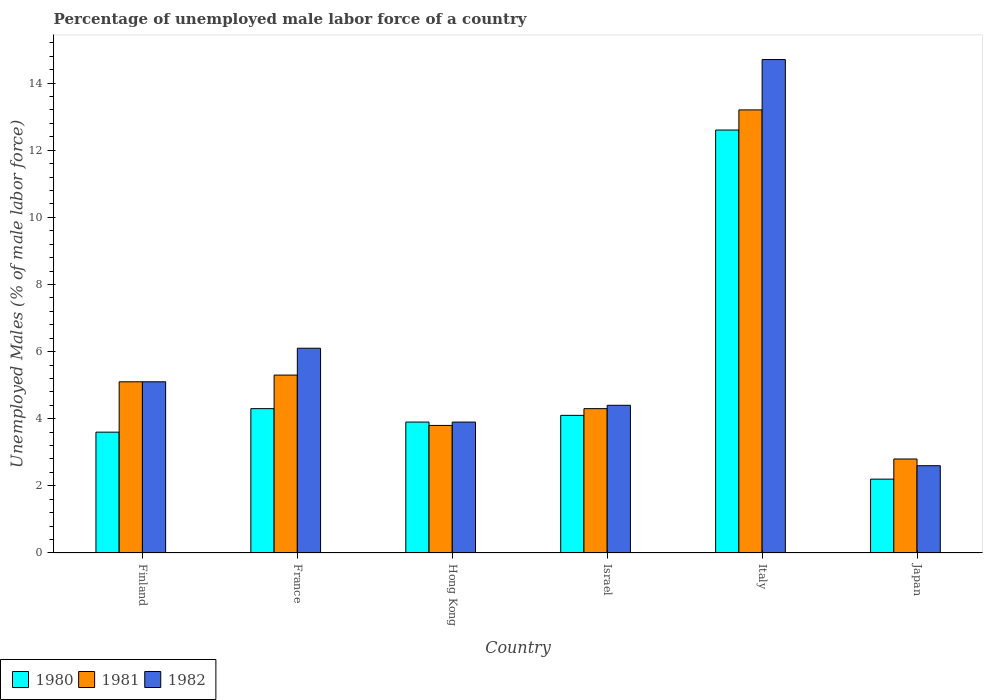How many different coloured bars are there?
Your answer should be very brief. 3. Are the number of bars per tick equal to the number of legend labels?
Your answer should be very brief. Yes. How many bars are there on the 5th tick from the right?
Provide a succinct answer. 3. What is the label of the 3rd group of bars from the left?
Make the answer very short. Hong Kong. What is the percentage of unemployed male labor force in 1981 in France?
Your answer should be very brief. 5.3. Across all countries, what is the maximum percentage of unemployed male labor force in 1982?
Provide a succinct answer. 14.7. Across all countries, what is the minimum percentage of unemployed male labor force in 1982?
Offer a very short reply. 2.6. In which country was the percentage of unemployed male labor force in 1980 maximum?
Your answer should be compact. Italy. What is the total percentage of unemployed male labor force in 1980 in the graph?
Give a very brief answer. 30.7. What is the difference between the percentage of unemployed male labor force in 1981 in France and that in Japan?
Offer a very short reply. 2.5. What is the difference between the percentage of unemployed male labor force in 1982 in Finland and the percentage of unemployed male labor force in 1980 in France?
Provide a succinct answer. 0.8. What is the average percentage of unemployed male labor force in 1981 per country?
Your response must be concise. 5.75. What is the difference between the percentage of unemployed male labor force of/in 1981 and percentage of unemployed male labor force of/in 1982 in Israel?
Your answer should be very brief. -0.1. What is the ratio of the percentage of unemployed male labor force in 1981 in Finland to that in Israel?
Offer a very short reply. 1.19. Is the difference between the percentage of unemployed male labor force in 1981 in Hong Kong and Italy greater than the difference between the percentage of unemployed male labor force in 1982 in Hong Kong and Italy?
Your response must be concise. Yes. What is the difference between the highest and the second highest percentage of unemployed male labor force in 1981?
Ensure brevity in your answer.  -7.9. What is the difference between the highest and the lowest percentage of unemployed male labor force in 1982?
Offer a very short reply. 12.1. In how many countries, is the percentage of unemployed male labor force in 1981 greater than the average percentage of unemployed male labor force in 1981 taken over all countries?
Your answer should be compact. 1. What does the 1st bar from the right in Japan represents?
Keep it short and to the point. 1982. How many bars are there?
Make the answer very short. 18. Are all the bars in the graph horizontal?
Offer a very short reply. No. How many countries are there in the graph?
Provide a succinct answer. 6. Where does the legend appear in the graph?
Make the answer very short. Bottom left. How many legend labels are there?
Your response must be concise. 3. What is the title of the graph?
Provide a succinct answer. Percentage of unemployed male labor force of a country. Does "1966" appear as one of the legend labels in the graph?
Make the answer very short. No. What is the label or title of the Y-axis?
Your answer should be compact. Unemployed Males (% of male labor force). What is the Unemployed Males (% of male labor force) in 1980 in Finland?
Provide a short and direct response. 3.6. What is the Unemployed Males (% of male labor force) in 1981 in Finland?
Make the answer very short. 5.1. What is the Unemployed Males (% of male labor force) of 1982 in Finland?
Your answer should be very brief. 5.1. What is the Unemployed Males (% of male labor force) in 1980 in France?
Keep it short and to the point. 4.3. What is the Unemployed Males (% of male labor force) of 1981 in France?
Keep it short and to the point. 5.3. What is the Unemployed Males (% of male labor force) of 1982 in France?
Offer a terse response. 6.1. What is the Unemployed Males (% of male labor force) of 1980 in Hong Kong?
Provide a short and direct response. 3.9. What is the Unemployed Males (% of male labor force) in 1981 in Hong Kong?
Provide a short and direct response. 3.8. What is the Unemployed Males (% of male labor force) of 1982 in Hong Kong?
Make the answer very short. 3.9. What is the Unemployed Males (% of male labor force) of 1980 in Israel?
Give a very brief answer. 4.1. What is the Unemployed Males (% of male labor force) in 1981 in Israel?
Your response must be concise. 4.3. What is the Unemployed Males (% of male labor force) of 1982 in Israel?
Your answer should be compact. 4.4. What is the Unemployed Males (% of male labor force) in 1980 in Italy?
Keep it short and to the point. 12.6. What is the Unemployed Males (% of male labor force) in 1981 in Italy?
Ensure brevity in your answer.  13.2. What is the Unemployed Males (% of male labor force) in 1982 in Italy?
Provide a succinct answer. 14.7. What is the Unemployed Males (% of male labor force) of 1980 in Japan?
Provide a succinct answer. 2.2. What is the Unemployed Males (% of male labor force) in 1981 in Japan?
Your answer should be very brief. 2.8. What is the Unemployed Males (% of male labor force) of 1982 in Japan?
Your answer should be compact. 2.6. Across all countries, what is the maximum Unemployed Males (% of male labor force) in 1980?
Offer a very short reply. 12.6. Across all countries, what is the maximum Unemployed Males (% of male labor force) of 1981?
Keep it short and to the point. 13.2. Across all countries, what is the maximum Unemployed Males (% of male labor force) in 1982?
Offer a terse response. 14.7. Across all countries, what is the minimum Unemployed Males (% of male labor force) of 1980?
Keep it short and to the point. 2.2. Across all countries, what is the minimum Unemployed Males (% of male labor force) in 1981?
Your response must be concise. 2.8. Across all countries, what is the minimum Unemployed Males (% of male labor force) of 1982?
Your response must be concise. 2.6. What is the total Unemployed Males (% of male labor force) in 1980 in the graph?
Provide a short and direct response. 30.7. What is the total Unemployed Males (% of male labor force) of 1981 in the graph?
Your response must be concise. 34.5. What is the total Unemployed Males (% of male labor force) in 1982 in the graph?
Provide a short and direct response. 36.8. What is the difference between the Unemployed Males (% of male labor force) of 1981 in Finland and that in France?
Your response must be concise. -0.2. What is the difference between the Unemployed Males (% of male labor force) of 1980 in Finland and that in Hong Kong?
Your answer should be compact. -0.3. What is the difference between the Unemployed Males (% of male labor force) of 1980 in Finland and that in Israel?
Provide a succinct answer. -0.5. What is the difference between the Unemployed Males (% of male labor force) of 1982 in Finland and that in Israel?
Provide a short and direct response. 0.7. What is the difference between the Unemployed Males (% of male labor force) in 1981 in Finland and that in Italy?
Provide a succinct answer. -8.1. What is the difference between the Unemployed Males (% of male labor force) of 1982 in Finland and that in Italy?
Your answer should be very brief. -9.6. What is the difference between the Unemployed Males (% of male labor force) of 1982 in Finland and that in Japan?
Give a very brief answer. 2.5. What is the difference between the Unemployed Males (% of male labor force) of 1980 in France and that in Hong Kong?
Offer a terse response. 0.4. What is the difference between the Unemployed Males (% of male labor force) in 1980 in France and that in Israel?
Ensure brevity in your answer.  0.2. What is the difference between the Unemployed Males (% of male labor force) in 1981 in France and that in Israel?
Your answer should be compact. 1. What is the difference between the Unemployed Males (% of male labor force) in 1981 in France and that in Italy?
Make the answer very short. -7.9. What is the difference between the Unemployed Males (% of male labor force) of 1980 in France and that in Japan?
Provide a succinct answer. 2.1. What is the difference between the Unemployed Males (% of male labor force) of 1981 in France and that in Japan?
Provide a succinct answer. 2.5. What is the difference between the Unemployed Males (% of male labor force) of 1980 in Hong Kong and that in Israel?
Make the answer very short. -0.2. What is the difference between the Unemployed Males (% of male labor force) of 1982 in Hong Kong and that in Israel?
Provide a succinct answer. -0.5. What is the difference between the Unemployed Males (% of male labor force) of 1980 in Hong Kong and that in Italy?
Offer a terse response. -8.7. What is the difference between the Unemployed Males (% of male labor force) of 1981 in Hong Kong and that in Italy?
Make the answer very short. -9.4. What is the difference between the Unemployed Males (% of male labor force) in 1980 in Israel and that in Italy?
Ensure brevity in your answer.  -8.5. What is the difference between the Unemployed Males (% of male labor force) in 1982 in Israel and that in Italy?
Your answer should be very brief. -10.3. What is the difference between the Unemployed Males (% of male labor force) in 1981 in Israel and that in Japan?
Your answer should be very brief. 1.5. What is the difference between the Unemployed Males (% of male labor force) of 1982 in Israel and that in Japan?
Your response must be concise. 1.8. What is the difference between the Unemployed Males (% of male labor force) in 1981 in Italy and that in Japan?
Keep it short and to the point. 10.4. What is the difference between the Unemployed Males (% of male labor force) of 1982 in Italy and that in Japan?
Give a very brief answer. 12.1. What is the difference between the Unemployed Males (% of male labor force) of 1981 in Finland and the Unemployed Males (% of male labor force) of 1982 in France?
Make the answer very short. -1. What is the difference between the Unemployed Males (% of male labor force) in 1980 in Finland and the Unemployed Males (% of male labor force) in 1981 in Hong Kong?
Give a very brief answer. -0.2. What is the difference between the Unemployed Males (% of male labor force) in 1980 in Finland and the Unemployed Males (% of male labor force) in 1982 in Hong Kong?
Ensure brevity in your answer.  -0.3. What is the difference between the Unemployed Males (% of male labor force) of 1981 in Finland and the Unemployed Males (% of male labor force) of 1982 in Hong Kong?
Your answer should be very brief. 1.2. What is the difference between the Unemployed Males (% of male labor force) in 1981 in Finland and the Unemployed Males (% of male labor force) in 1982 in Israel?
Offer a very short reply. 0.7. What is the difference between the Unemployed Males (% of male labor force) of 1980 in Finland and the Unemployed Males (% of male labor force) of 1982 in Italy?
Offer a terse response. -11.1. What is the difference between the Unemployed Males (% of male labor force) in 1981 in Finland and the Unemployed Males (% of male labor force) in 1982 in Italy?
Offer a terse response. -9.6. What is the difference between the Unemployed Males (% of male labor force) of 1980 in Finland and the Unemployed Males (% of male labor force) of 1982 in Japan?
Give a very brief answer. 1. What is the difference between the Unemployed Males (% of male labor force) in 1981 in France and the Unemployed Males (% of male labor force) in 1982 in Hong Kong?
Make the answer very short. 1.4. What is the difference between the Unemployed Males (% of male labor force) in 1980 in France and the Unemployed Males (% of male labor force) in 1981 in Italy?
Keep it short and to the point. -8.9. What is the difference between the Unemployed Males (% of male labor force) of 1980 in France and the Unemployed Males (% of male labor force) of 1982 in Japan?
Provide a short and direct response. 1.7. What is the difference between the Unemployed Males (% of male labor force) of 1980 in Hong Kong and the Unemployed Males (% of male labor force) of 1981 in Israel?
Offer a very short reply. -0.4. What is the difference between the Unemployed Males (% of male labor force) in 1981 in Hong Kong and the Unemployed Males (% of male labor force) in 1982 in Israel?
Make the answer very short. -0.6. What is the difference between the Unemployed Males (% of male labor force) in 1980 in Hong Kong and the Unemployed Males (% of male labor force) in 1982 in Italy?
Offer a very short reply. -10.8. What is the difference between the Unemployed Males (% of male labor force) of 1980 in Hong Kong and the Unemployed Males (% of male labor force) of 1981 in Japan?
Offer a very short reply. 1.1. What is the difference between the Unemployed Males (% of male labor force) of 1980 in Israel and the Unemployed Males (% of male labor force) of 1982 in Italy?
Make the answer very short. -10.6. What is the difference between the Unemployed Males (% of male labor force) of 1981 in Israel and the Unemployed Males (% of male labor force) of 1982 in Italy?
Your answer should be very brief. -10.4. What is the difference between the Unemployed Males (% of male labor force) in 1980 in Israel and the Unemployed Males (% of male labor force) in 1981 in Japan?
Your answer should be very brief. 1.3. What is the difference between the Unemployed Males (% of male labor force) in 1980 in Israel and the Unemployed Males (% of male labor force) in 1982 in Japan?
Keep it short and to the point. 1.5. What is the difference between the Unemployed Males (% of male labor force) in 1981 in Israel and the Unemployed Males (% of male labor force) in 1982 in Japan?
Provide a short and direct response. 1.7. What is the difference between the Unemployed Males (% of male labor force) of 1981 in Italy and the Unemployed Males (% of male labor force) of 1982 in Japan?
Provide a short and direct response. 10.6. What is the average Unemployed Males (% of male labor force) of 1980 per country?
Provide a succinct answer. 5.12. What is the average Unemployed Males (% of male labor force) of 1981 per country?
Your response must be concise. 5.75. What is the average Unemployed Males (% of male labor force) of 1982 per country?
Provide a succinct answer. 6.13. What is the difference between the Unemployed Males (% of male labor force) in 1980 and Unemployed Males (% of male labor force) in 1981 in Finland?
Your response must be concise. -1.5. What is the difference between the Unemployed Males (% of male labor force) in 1981 and Unemployed Males (% of male labor force) in 1982 in Finland?
Offer a very short reply. 0. What is the difference between the Unemployed Males (% of male labor force) of 1981 and Unemployed Males (% of male labor force) of 1982 in France?
Keep it short and to the point. -0.8. What is the difference between the Unemployed Males (% of male labor force) of 1980 and Unemployed Males (% of male labor force) of 1982 in Hong Kong?
Offer a terse response. 0. What is the difference between the Unemployed Males (% of male labor force) in 1980 and Unemployed Males (% of male labor force) in 1981 in Israel?
Offer a very short reply. -0.2. What is the difference between the Unemployed Males (% of male labor force) in 1980 and Unemployed Males (% of male labor force) in 1982 in Israel?
Your answer should be very brief. -0.3. What is the difference between the Unemployed Males (% of male labor force) in 1980 and Unemployed Males (% of male labor force) in 1982 in Italy?
Your answer should be very brief. -2.1. What is the difference between the Unemployed Males (% of male labor force) of 1980 and Unemployed Males (% of male labor force) of 1981 in Japan?
Offer a very short reply. -0.6. What is the ratio of the Unemployed Males (% of male labor force) in 1980 in Finland to that in France?
Make the answer very short. 0.84. What is the ratio of the Unemployed Males (% of male labor force) in 1981 in Finland to that in France?
Your answer should be very brief. 0.96. What is the ratio of the Unemployed Males (% of male labor force) in 1982 in Finland to that in France?
Provide a short and direct response. 0.84. What is the ratio of the Unemployed Males (% of male labor force) of 1981 in Finland to that in Hong Kong?
Your answer should be very brief. 1.34. What is the ratio of the Unemployed Males (% of male labor force) in 1982 in Finland to that in Hong Kong?
Your answer should be compact. 1.31. What is the ratio of the Unemployed Males (% of male labor force) in 1980 in Finland to that in Israel?
Provide a short and direct response. 0.88. What is the ratio of the Unemployed Males (% of male labor force) in 1981 in Finland to that in Israel?
Give a very brief answer. 1.19. What is the ratio of the Unemployed Males (% of male labor force) in 1982 in Finland to that in Israel?
Provide a succinct answer. 1.16. What is the ratio of the Unemployed Males (% of male labor force) in 1980 in Finland to that in Italy?
Your response must be concise. 0.29. What is the ratio of the Unemployed Males (% of male labor force) of 1981 in Finland to that in Italy?
Make the answer very short. 0.39. What is the ratio of the Unemployed Males (% of male labor force) of 1982 in Finland to that in Italy?
Give a very brief answer. 0.35. What is the ratio of the Unemployed Males (% of male labor force) of 1980 in Finland to that in Japan?
Your answer should be very brief. 1.64. What is the ratio of the Unemployed Males (% of male labor force) in 1981 in Finland to that in Japan?
Offer a terse response. 1.82. What is the ratio of the Unemployed Males (% of male labor force) of 1982 in Finland to that in Japan?
Your response must be concise. 1.96. What is the ratio of the Unemployed Males (% of male labor force) in 1980 in France to that in Hong Kong?
Offer a very short reply. 1.1. What is the ratio of the Unemployed Males (% of male labor force) in 1981 in France to that in Hong Kong?
Offer a very short reply. 1.39. What is the ratio of the Unemployed Males (% of male labor force) of 1982 in France to that in Hong Kong?
Keep it short and to the point. 1.56. What is the ratio of the Unemployed Males (% of male labor force) of 1980 in France to that in Israel?
Offer a very short reply. 1.05. What is the ratio of the Unemployed Males (% of male labor force) of 1981 in France to that in Israel?
Offer a very short reply. 1.23. What is the ratio of the Unemployed Males (% of male labor force) in 1982 in France to that in Israel?
Your answer should be compact. 1.39. What is the ratio of the Unemployed Males (% of male labor force) of 1980 in France to that in Italy?
Make the answer very short. 0.34. What is the ratio of the Unemployed Males (% of male labor force) in 1981 in France to that in Italy?
Ensure brevity in your answer.  0.4. What is the ratio of the Unemployed Males (% of male labor force) of 1982 in France to that in Italy?
Give a very brief answer. 0.41. What is the ratio of the Unemployed Males (% of male labor force) in 1980 in France to that in Japan?
Provide a short and direct response. 1.95. What is the ratio of the Unemployed Males (% of male labor force) of 1981 in France to that in Japan?
Your answer should be very brief. 1.89. What is the ratio of the Unemployed Males (% of male labor force) in 1982 in France to that in Japan?
Your answer should be compact. 2.35. What is the ratio of the Unemployed Males (% of male labor force) in 1980 in Hong Kong to that in Israel?
Provide a succinct answer. 0.95. What is the ratio of the Unemployed Males (% of male labor force) in 1981 in Hong Kong to that in Israel?
Your answer should be compact. 0.88. What is the ratio of the Unemployed Males (% of male labor force) of 1982 in Hong Kong to that in Israel?
Ensure brevity in your answer.  0.89. What is the ratio of the Unemployed Males (% of male labor force) in 1980 in Hong Kong to that in Italy?
Your answer should be very brief. 0.31. What is the ratio of the Unemployed Males (% of male labor force) of 1981 in Hong Kong to that in Italy?
Offer a very short reply. 0.29. What is the ratio of the Unemployed Males (% of male labor force) of 1982 in Hong Kong to that in Italy?
Your answer should be compact. 0.27. What is the ratio of the Unemployed Males (% of male labor force) of 1980 in Hong Kong to that in Japan?
Your answer should be compact. 1.77. What is the ratio of the Unemployed Males (% of male labor force) in 1981 in Hong Kong to that in Japan?
Give a very brief answer. 1.36. What is the ratio of the Unemployed Males (% of male labor force) in 1980 in Israel to that in Italy?
Provide a short and direct response. 0.33. What is the ratio of the Unemployed Males (% of male labor force) in 1981 in Israel to that in Italy?
Keep it short and to the point. 0.33. What is the ratio of the Unemployed Males (% of male labor force) of 1982 in Israel to that in Italy?
Make the answer very short. 0.3. What is the ratio of the Unemployed Males (% of male labor force) of 1980 in Israel to that in Japan?
Offer a terse response. 1.86. What is the ratio of the Unemployed Males (% of male labor force) in 1981 in Israel to that in Japan?
Provide a succinct answer. 1.54. What is the ratio of the Unemployed Males (% of male labor force) of 1982 in Israel to that in Japan?
Provide a short and direct response. 1.69. What is the ratio of the Unemployed Males (% of male labor force) in 1980 in Italy to that in Japan?
Your answer should be very brief. 5.73. What is the ratio of the Unemployed Males (% of male labor force) in 1981 in Italy to that in Japan?
Provide a succinct answer. 4.71. What is the ratio of the Unemployed Males (% of male labor force) of 1982 in Italy to that in Japan?
Provide a short and direct response. 5.65. What is the difference between the highest and the lowest Unemployed Males (% of male labor force) in 1980?
Provide a succinct answer. 10.4. 